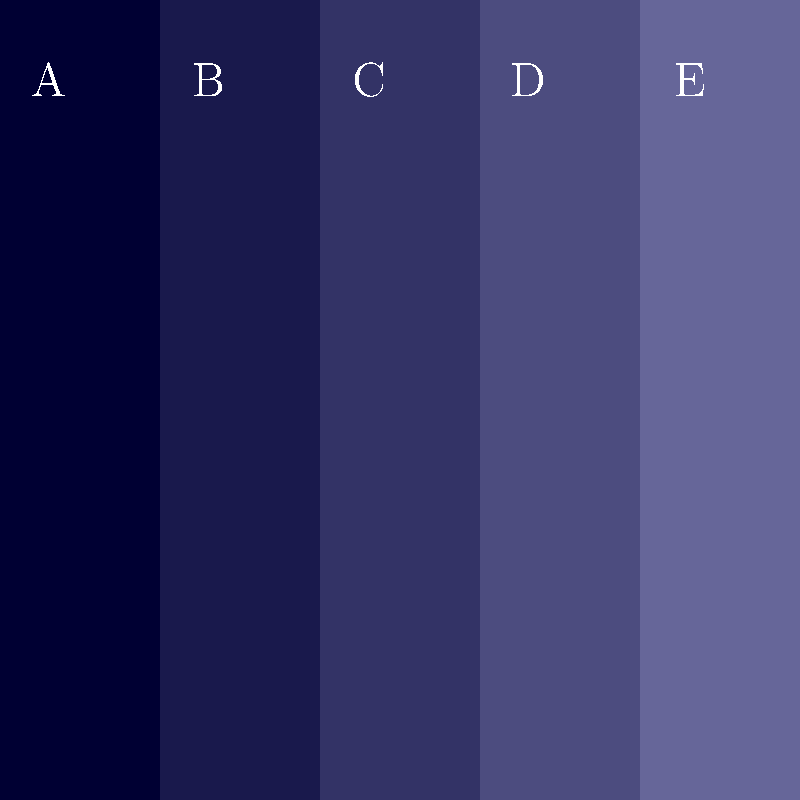Which color gradient sequence best represents a deep space backdrop for a galactic-themed wedding, progressing from darkest to lightest? To determine the correct color gradient for a space-themed backdrop, we need to consider the following steps:

1. Analyze the color strips from left to right (A to E).
2. Identify the darkest and lightest shades.
3. Determine if there's a smooth transition between shades.

Looking at the image:
A: Darkest shade of blue (almost black)
B: Slightly lighter than A
C: Midtone blue
D: Lighter blue
E: Lightest shade of blue

The gradient progresses smoothly from darkest (A) to lightest (E), which accurately represents the gradual lightening of the night sky from deep space to a lighter blue often seen in space imagery.

This progression mimics the visual effect of light scattering in space, creating a realistic and visually appealing backdrop for a galactic-themed wedding.
Answer: A-B-C-D-E 